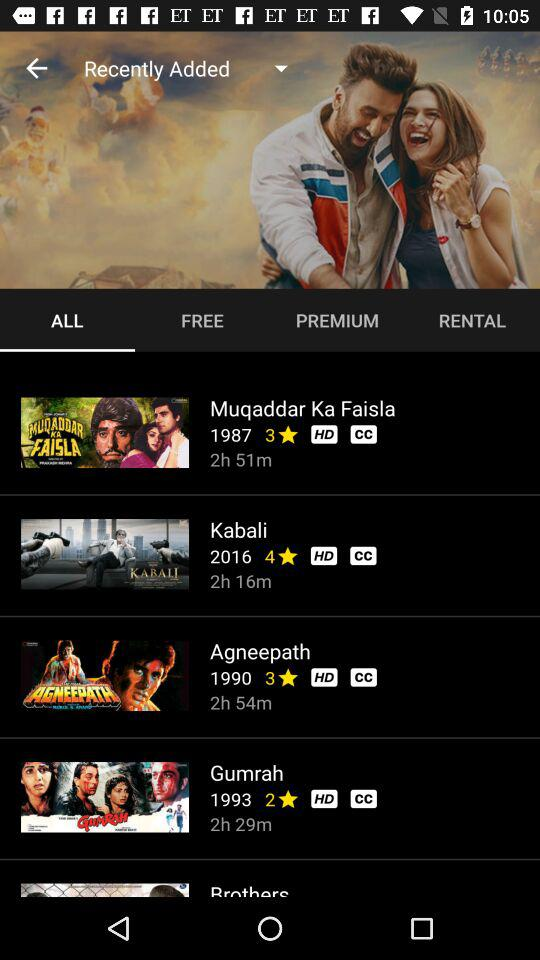What is the rating of the movie "Kabali"? The rating is 4 stars. 